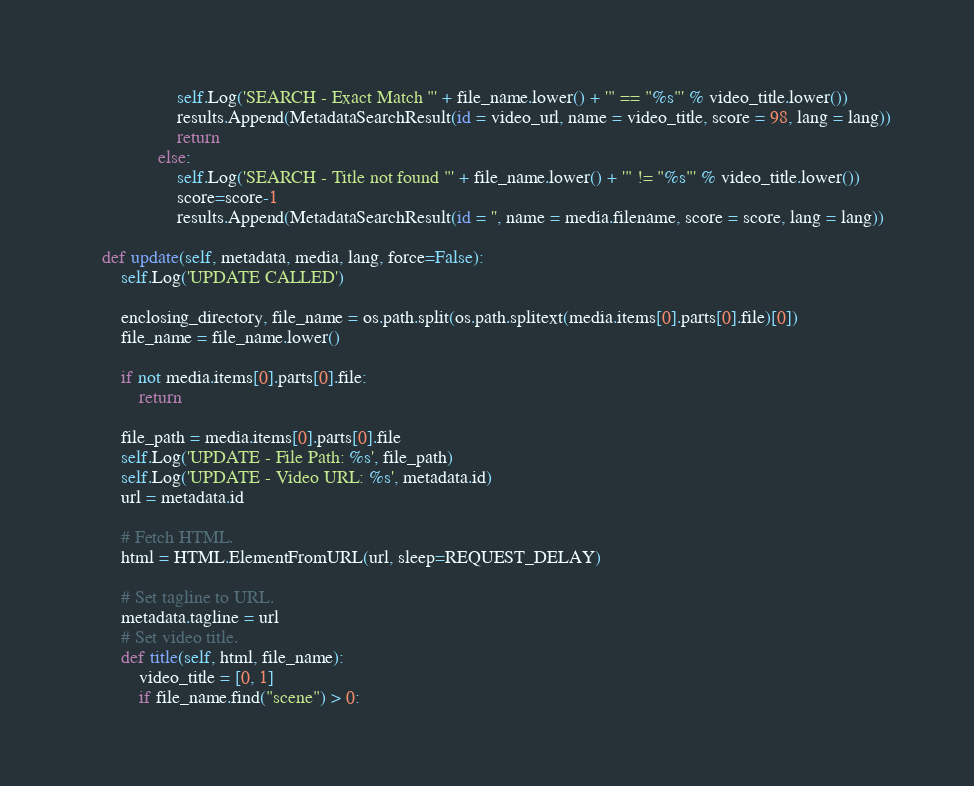<code> <loc_0><loc_0><loc_500><loc_500><_Python_>					self.Log('SEARCH - Exact Match "' + file_name.lower() + '" == "%s"' % video_title.lower())
					results.Append(MetadataSearchResult(id = video_url, name = video_title, score = 98, lang = lang))
					return
				else:
					self.Log('SEARCH - Title not found "' + file_name.lower() + '" != "%s"' % video_title.lower())
					score=score-1
					results.Append(MetadataSearchResult(id = '', name = media.filename, score = score, lang = lang))

	def update(self, metadata, media, lang, force=False):
		self.Log('UPDATE CALLED')

		enclosing_directory, file_name = os.path.split(os.path.splitext(media.items[0].parts[0].file)[0])
		file_name = file_name.lower()

		if not media.items[0].parts[0].file:
			return

		file_path = media.items[0].parts[0].file
		self.Log('UPDATE - File Path: %s', file_path)
		self.Log('UPDATE - Video URL: %s', metadata.id)
		url = metadata.id

		# Fetch HTML.
		html = HTML.ElementFromURL(url, sleep=REQUEST_DELAY)

		# Set tagline to URL.
		metadata.tagline = url
		# Set video title.
		def title(self, html, file_name):
			video_title = [0, 1]
			if file_name.find("scene") > 0:</code> 